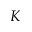Convert formula to latex. <formula><loc_0><loc_0><loc_500><loc_500>K</formula> 